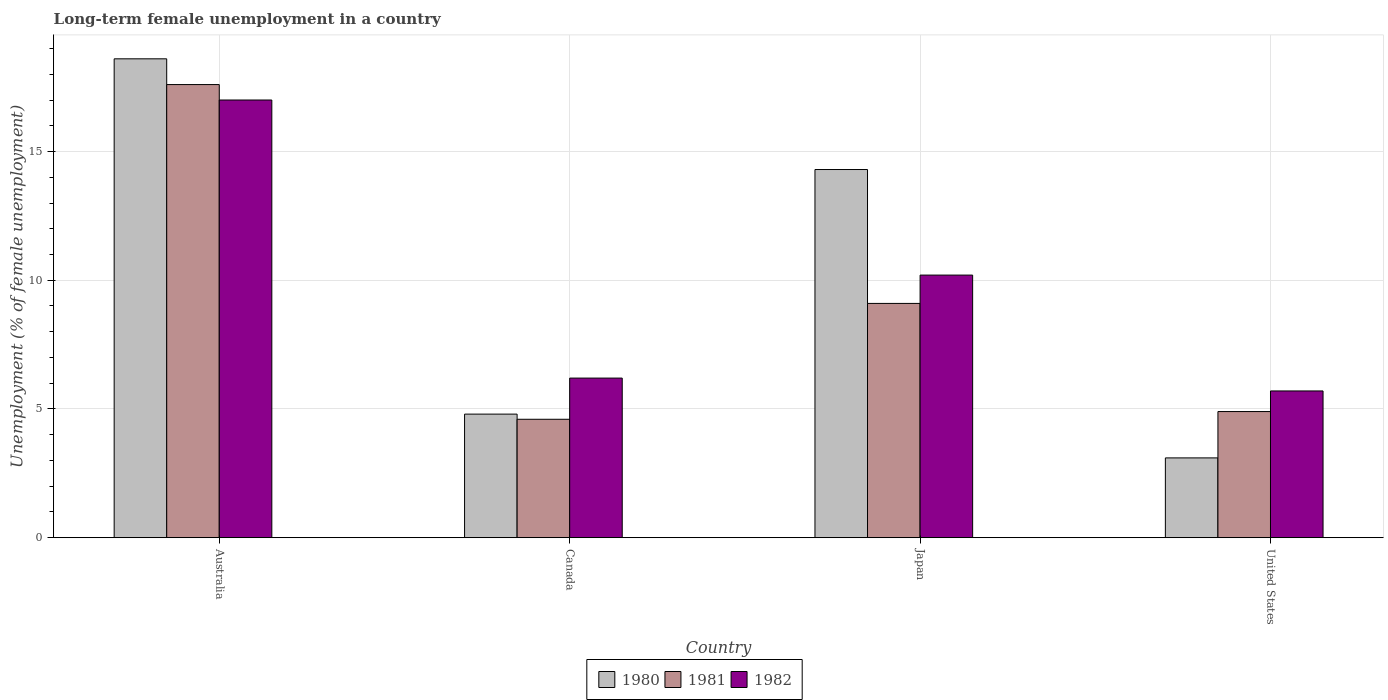How many different coloured bars are there?
Provide a short and direct response. 3. Are the number of bars per tick equal to the number of legend labels?
Offer a very short reply. Yes. How many bars are there on the 3rd tick from the left?
Make the answer very short. 3. What is the label of the 2nd group of bars from the left?
Provide a succinct answer. Canada. In how many cases, is the number of bars for a given country not equal to the number of legend labels?
Your response must be concise. 0. Across all countries, what is the minimum percentage of long-term unemployed female population in 1981?
Provide a short and direct response. 4.6. In which country was the percentage of long-term unemployed female population in 1982 maximum?
Provide a short and direct response. Australia. In which country was the percentage of long-term unemployed female population in 1980 minimum?
Keep it short and to the point. United States. What is the total percentage of long-term unemployed female population in 1982 in the graph?
Make the answer very short. 39.1. What is the difference between the percentage of long-term unemployed female population in 1982 in Australia and that in Japan?
Keep it short and to the point. 6.8. What is the difference between the percentage of long-term unemployed female population in 1982 in Canada and the percentage of long-term unemployed female population in 1980 in Japan?
Your answer should be compact. -8.1. What is the average percentage of long-term unemployed female population in 1980 per country?
Make the answer very short. 10.2. What is the difference between the percentage of long-term unemployed female population of/in 1981 and percentage of long-term unemployed female population of/in 1980 in Canada?
Keep it short and to the point. -0.2. What is the ratio of the percentage of long-term unemployed female population in 1980 in Japan to that in United States?
Your answer should be very brief. 4.61. What is the difference between the highest and the second highest percentage of long-term unemployed female population in 1981?
Your answer should be compact. 12.7. What is the difference between the highest and the lowest percentage of long-term unemployed female population in 1982?
Offer a very short reply. 11.3. What does the 3rd bar from the left in United States represents?
Offer a very short reply. 1982. Is it the case that in every country, the sum of the percentage of long-term unemployed female population in 1980 and percentage of long-term unemployed female population in 1981 is greater than the percentage of long-term unemployed female population in 1982?
Keep it short and to the point. Yes. How many bars are there?
Offer a very short reply. 12. Are all the bars in the graph horizontal?
Your answer should be compact. No. How many countries are there in the graph?
Make the answer very short. 4. What is the difference between two consecutive major ticks on the Y-axis?
Ensure brevity in your answer.  5. Where does the legend appear in the graph?
Make the answer very short. Bottom center. What is the title of the graph?
Give a very brief answer. Long-term female unemployment in a country. Does "2011" appear as one of the legend labels in the graph?
Keep it short and to the point. No. What is the label or title of the X-axis?
Keep it short and to the point. Country. What is the label or title of the Y-axis?
Ensure brevity in your answer.  Unemployment (% of female unemployment). What is the Unemployment (% of female unemployment) of 1980 in Australia?
Provide a succinct answer. 18.6. What is the Unemployment (% of female unemployment) in 1981 in Australia?
Provide a succinct answer. 17.6. What is the Unemployment (% of female unemployment) of 1982 in Australia?
Offer a very short reply. 17. What is the Unemployment (% of female unemployment) of 1980 in Canada?
Your answer should be very brief. 4.8. What is the Unemployment (% of female unemployment) in 1981 in Canada?
Your response must be concise. 4.6. What is the Unemployment (% of female unemployment) of 1982 in Canada?
Your answer should be very brief. 6.2. What is the Unemployment (% of female unemployment) in 1980 in Japan?
Your response must be concise. 14.3. What is the Unemployment (% of female unemployment) in 1981 in Japan?
Offer a terse response. 9.1. What is the Unemployment (% of female unemployment) in 1982 in Japan?
Offer a terse response. 10.2. What is the Unemployment (% of female unemployment) in 1980 in United States?
Offer a terse response. 3.1. What is the Unemployment (% of female unemployment) of 1981 in United States?
Keep it short and to the point. 4.9. What is the Unemployment (% of female unemployment) of 1982 in United States?
Provide a short and direct response. 5.7. Across all countries, what is the maximum Unemployment (% of female unemployment) of 1980?
Offer a terse response. 18.6. Across all countries, what is the maximum Unemployment (% of female unemployment) of 1981?
Your response must be concise. 17.6. Across all countries, what is the maximum Unemployment (% of female unemployment) of 1982?
Offer a terse response. 17. Across all countries, what is the minimum Unemployment (% of female unemployment) of 1980?
Keep it short and to the point. 3.1. Across all countries, what is the minimum Unemployment (% of female unemployment) of 1981?
Offer a terse response. 4.6. Across all countries, what is the minimum Unemployment (% of female unemployment) in 1982?
Your answer should be very brief. 5.7. What is the total Unemployment (% of female unemployment) of 1980 in the graph?
Provide a short and direct response. 40.8. What is the total Unemployment (% of female unemployment) in 1981 in the graph?
Keep it short and to the point. 36.2. What is the total Unemployment (% of female unemployment) in 1982 in the graph?
Give a very brief answer. 39.1. What is the difference between the Unemployment (% of female unemployment) in 1981 in Australia and that in Japan?
Offer a terse response. 8.5. What is the difference between the Unemployment (% of female unemployment) in 1982 in Canada and that in Japan?
Your answer should be compact. -4. What is the difference between the Unemployment (% of female unemployment) of 1980 in Canada and that in United States?
Provide a succinct answer. 1.7. What is the difference between the Unemployment (% of female unemployment) in 1981 in Canada and that in United States?
Provide a succinct answer. -0.3. What is the difference between the Unemployment (% of female unemployment) in 1980 in Japan and that in United States?
Your response must be concise. 11.2. What is the difference between the Unemployment (% of female unemployment) of 1980 in Australia and the Unemployment (% of female unemployment) of 1982 in Canada?
Provide a short and direct response. 12.4. What is the difference between the Unemployment (% of female unemployment) in 1980 in Australia and the Unemployment (% of female unemployment) in 1981 in Japan?
Offer a very short reply. 9.5. What is the difference between the Unemployment (% of female unemployment) in 1980 in Australia and the Unemployment (% of female unemployment) in 1982 in Japan?
Your answer should be compact. 8.4. What is the difference between the Unemployment (% of female unemployment) in 1980 in Canada and the Unemployment (% of female unemployment) in 1982 in Japan?
Offer a terse response. -5.4. What is the difference between the Unemployment (% of female unemployment) in 1981 in Canada and the Unemployment (% of female unemployment) in 1982 in Japan?
Offer a terse response. -5.6. What is the difference between the Unemployment (% of female unemployment) in 1980 in Japan and the Unemployment (% of female unemployment) in 1982 in United States?
Provide a short and direct response. 8.6. What is the average Unemployment (% of female unemployment) in 1980 per country?
Your answer should be compact. 10.2. What is the average Unemployment (% of female unemployment) of 1981 per country?
Provide a succinct answer. 9.05. What is the average Unemployment (% of female unemployment) in 1982 per country?
Offer a very short reply. 9.78. What is the difference between the Unemployment (% of female unemployment) of 1981 and Unemployment (% of female unemployment) of 1982 in Australia?
Provide a succinct answer. 0.6. What is the difference between the Unemployment (% of female unemployment) of 1980 and Unemployment (% of female unemployment) of 1981 in Canada?
Provide a succinct answer. 0.2. What is the difference between the Unemployment (% of female unemployment) in 1981 and Unemployment (% of female unemployment) in 1982 in Canada?
Keep it short and to the point. -1.6. What is the difference between the Unemployment (% of female unemployment) in 1980 and Unemployment (% of female unemployment) in 1981 in Japan?
Offer a terse response. 5.2. What is the difference between the Unemployment (% of female unemployment) in 1980 and Unemployment (% of female unemployment) in 1982 in Japan?
Make the answer very short. 4.1. What is the difference between the Unemployment (% of female unemployment) in 1981 and Unemployment (% of female unemployment) in 1982 in Japan?
Give a very brief answer. -1.1. What is the ratio of the Unemployment (% of female unemployment) in 1980 in Australia to that in Canada?
Ensure brevity in your answer.  3.88. What is the ratio of the Unemployment (% of female unemployment) in 1981 in Australia to that in Canada?
Provide a short and direct response. 3.83. What is the ratio of the Unemployment (% of female unemployment) in 1982 in Australia to that in Canada?
Provide a short and direct response. 2.74. What is the ratio of the Unemployment (% of female unemployment) of 1980 in Australia to that in Japan?
Provide a short and direct response. 1.3. What is the ratio of the Unemployment (% of female unemployment) of 1981 in Australia to that in Japan?
Offer a terse response. 1.93. What is the ratio of the Unemployment (% of female unemployment) in 1981 in Australia to that in United States?
Give a very brief answer. 3.59. What is the ratio of the Unemployment (% of female unemployment) of 1982 in Australia to that in United States?
Offer a very short reply. 2.98. What is the ratio of the Unemployment (% of female unemployment) of 1980 in Canada to that in Japan?
Ensure brevity in your answer.  0.34. What is the ratio of the Unemployment (% of female unemployment) of 1981 in Canada to that in Japan?
Provide a succinct answer. 0.51. What is the ratio of the Unemployment (% of female unemployment) of 1982 in Canada to that in Japan?
Ensure brevity in your answer.  0.61. What is the ratio of the Unemployment (% of female unemployment) of 1980 in Canada to that in United States?
Provide a succinct answer. 1.55. What is the ratio of the Unemployment (% of female unemployment) in 1981 in Canada to that in United States?
Your response must be concise. 0.94. What is the ratio of the Unemployment (% of female unemployment) of 1982 in Canada to that in United States?
Keep it short and to the point. 1.09. What is the ratio of the Unemployment (% of female unemployment) of 1980 in Japan to that in United States?
Offer a very short reply. 4.61. What is the ratio of the Unemployment (% of female unemployment) in 1981 in Japan to that in United States?
Give a very brief answer. 1.86. What is the ratio of the Unemployment (% of female unemployment) in 1982 in Japan to that in United States?
Your answer should be very brief. 1.79. What is the difference between the highest and the second highest Unemployment (% of female unemployment) of 1980?
Offer a very short reply. 4.3. What is the difference between the highest and the second highest Unemployment (% of female unemployment) in 1982?
Offer a very short reply. 6.8. What is the difference between the highest and the lowest Unemployment (% of female unemployment) of 1980?
Offer a terse response. 15.5. 